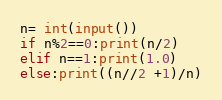Convert code to text. <code><loc_0><loc_0><loc_500><loc_500><_Python_>n= int(input())
if n%2==0:print(n/2)
elif n==1:print(1.0)
else:print((n//2 +1)/n)</code> 